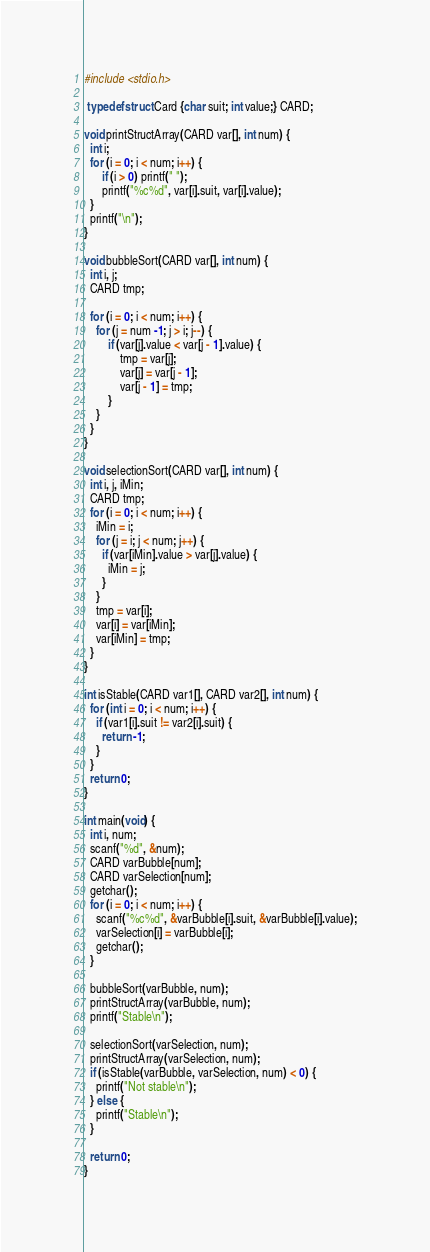Convert code to text. <code><loc_0><loc_0><loc_500><loc_500><_C_>#include <stdio.h>

 typedef struct Card {char suit; int value;} CARD;

void printStructArray(CARD var[], int num) {
  int i;
  for (i = 0; i < num; i++) {
      if (i > 0) printf(" ");
      printf("%c%d", var[i].suit, var[i].value);
  }
  printf("\n");
}

void bubbleSort(CARD var[], int num) {
  int i, j;
  CARD tmp;

  for (i = 0; i < num; i++) {
    for (j = num -1; j > i; j--) {
        if (var[j].value < var[j - 1].value) {
            tmp = var[j];
            var[j] = var[j - 1];
            var[j - 1] = tmp;
        }
    }
  }
}

void selectionSort(CARD var[], int num) {
  int i, j, iMin;
  CARD tmp;
  for (i = 0; i < num; i++) {
    iMin = i;
    for (j = i; j < num; j++) {
      if (var[iMin].value > var[j].value) {
        iMin = j;
      }
    }
    tmp = var[i];
    var[i] = var[iMin];
    var[iMin] = tmp;
  }
}

int isStable(CARD var1[], CARD var2[], int num) {
  for (int i = 0; i < num; i++) {
    if (var1[i].suit != var2[i].suit) {
      return -1;
    } 
  }
  return 0;
}

int main(void) {
  int i, num;
  scanf("%d", &num);
  CARD varBubble[num];
  CARD varSelection[num];
  getchar();
  for (i = 0; i < num; i++) {
    scanf("%c%d", &varBubble[i].suit, &varBubble[i].value);
    varSelection[i] = varBubble[i];
    getchar();
  }
  
  bubbleSort(varBubble, num);
  printStructArray(varBubble, num);
  printf("Stable\n");
  
  selectionSort(varSelection, num);
  printStructArray(varSelection, num);
  if (isStable(varBubble, varSelection, num) < 0) {
    printf("Not stable\n");
  } else {
    printf("Stable\n");
  }

  return 0;
}
</code> 